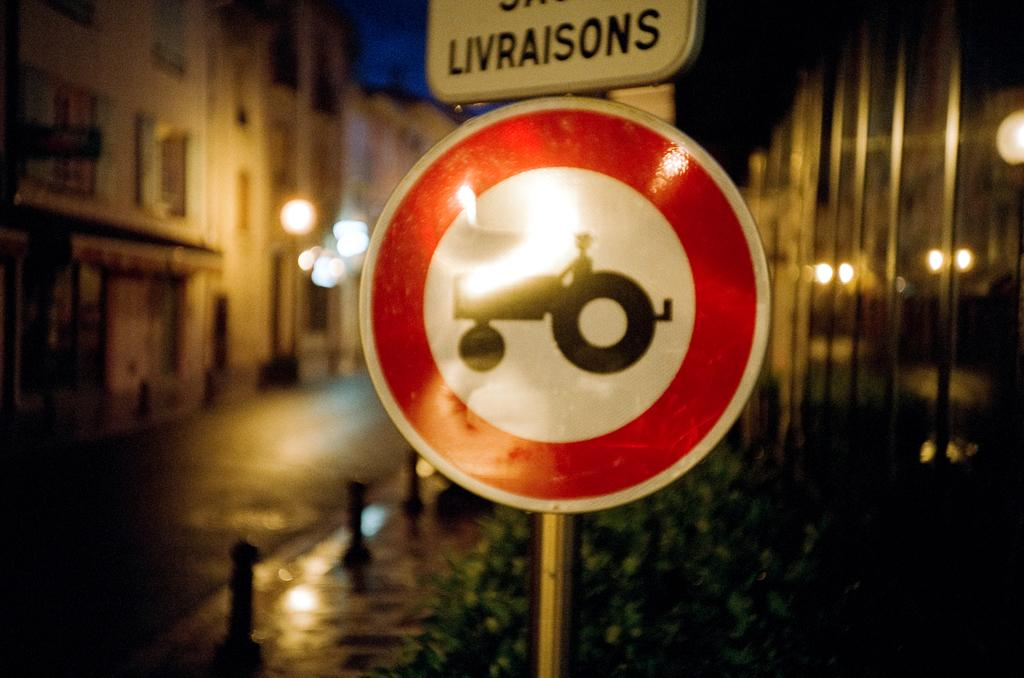<image>
Share a concise interpretation of the image provided. A sign with a tractor on it is below another sign that says Livraisons. 